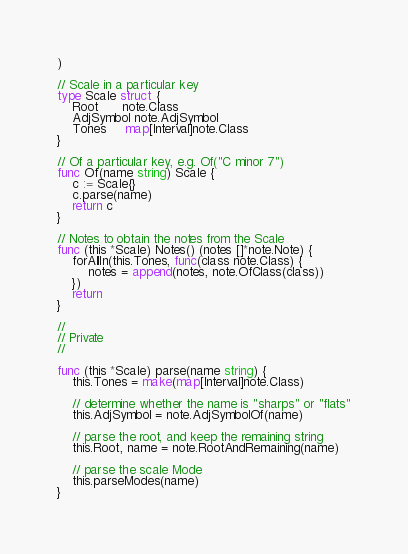Convert code to text. <code><loc_0><loc_0><loc_500><loc_500><_Go_>)

// Scale in a particular key
type Scale struct {
	Root      note.Class
	AdjSymbol note.AdjSymbol
	Tones     map[Interval]note.Class
}

// Of a particular key, e.g. Of("C minor 7")
func Of(name string) Scale {
	c := Scale{}
	c.parse(name)
	return c
}

// Notes to obtain the notes from the Scale
func (this *Scale) Notes() (notes []*note.Note) {
	forAllIn(this.Tones, func(class note.Class) {
		notes = append(notes, note.OfClass(class))
	})
	return
}

//
// Private
//

func (this *Scale) parse(name string) {
	this.Tones = make(map[Interval]note.Class)

	// determine whether the name is "sharps" or "flats"
	this.AdjSymbol = note.AdjSymbolOf(name)

	// parse the root, and keep the remaining string
	this.Root, name = note.RootAndRemaining(name)

	// parse the scale Mode
	this.parseModes(name)
}
</code> 